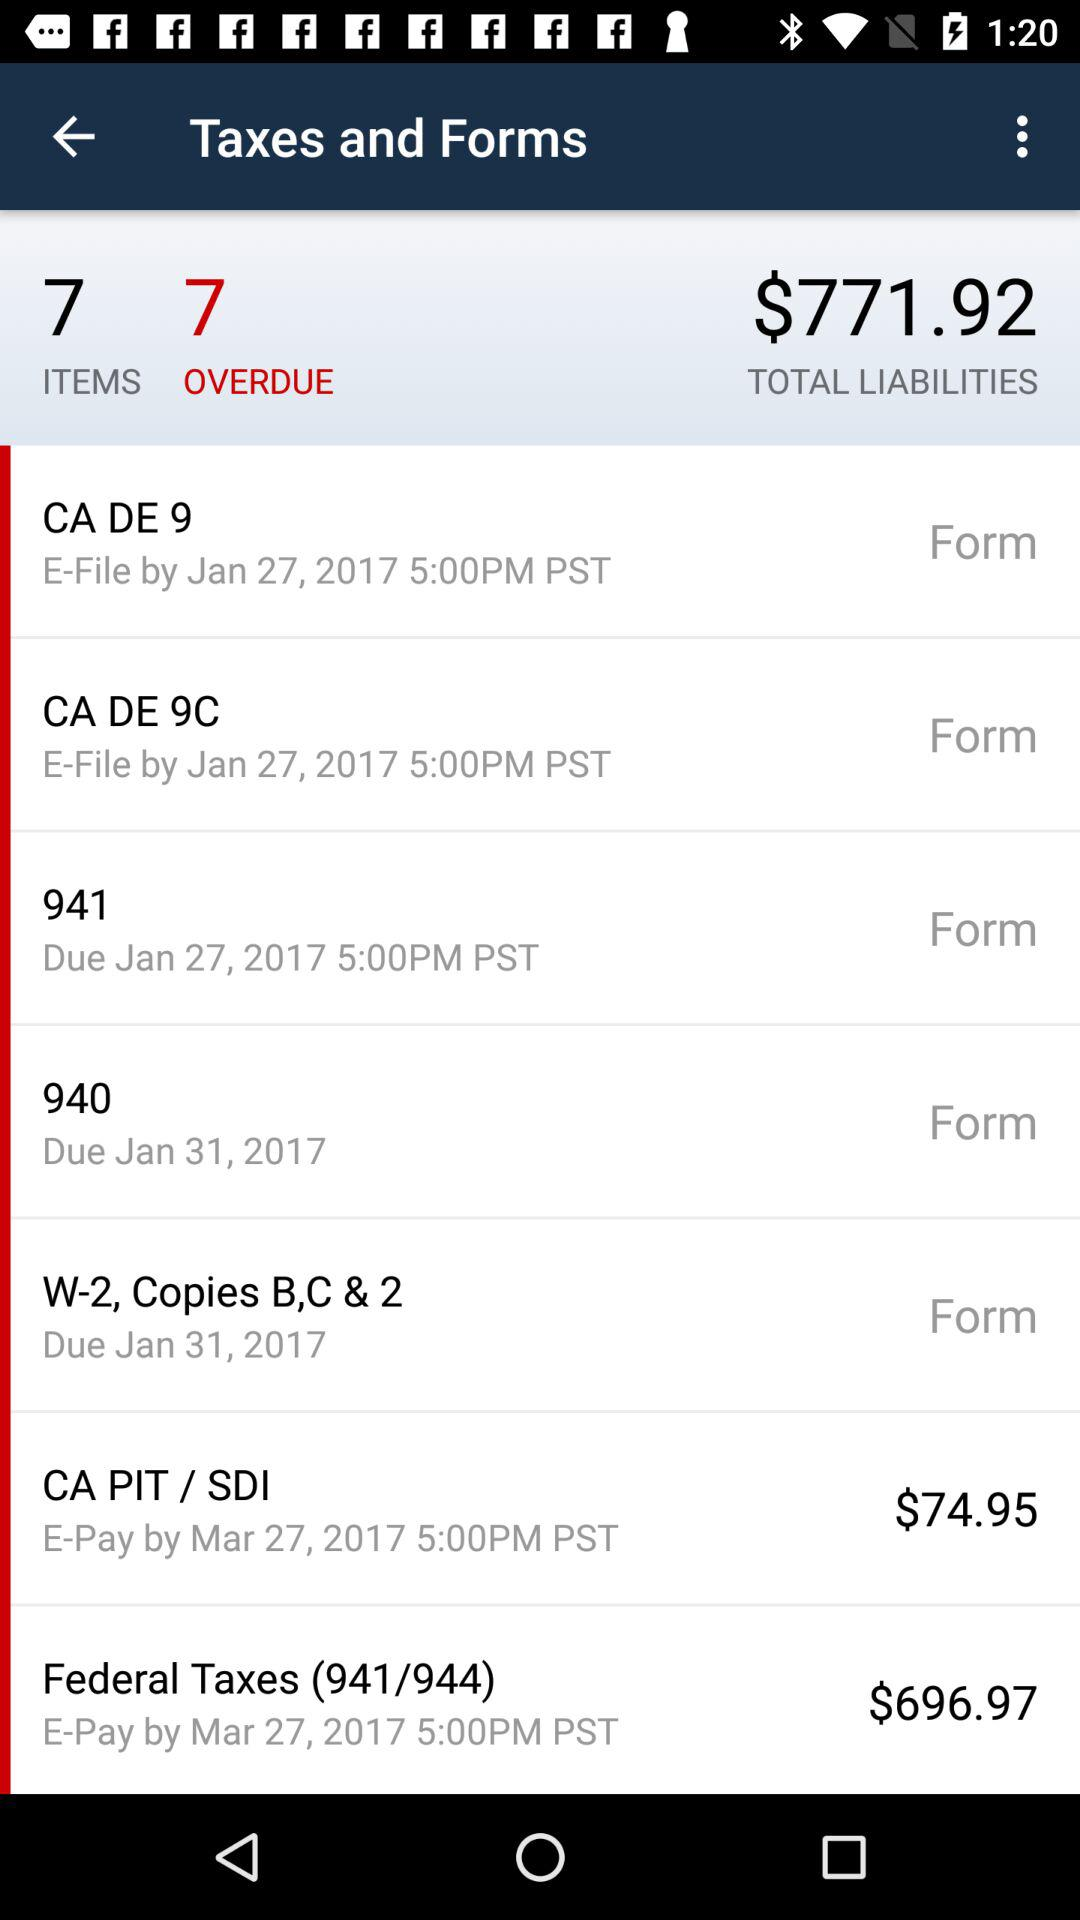What are the total liabilities? The total liabilities are $771.92. 